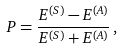<formula> <loc_0><loc_0><loc_500><loc_500>P = \frac { E ^ { ( S ) } - E ^ { ( A ) } } { E ^ { ( S ) } + E ^ { ( A ) } } \, ,</formula> 